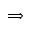Convert formula to latex. <formula><loc_0><loc_0><loc_500><loc_500>\Longrightarrow</formula> 